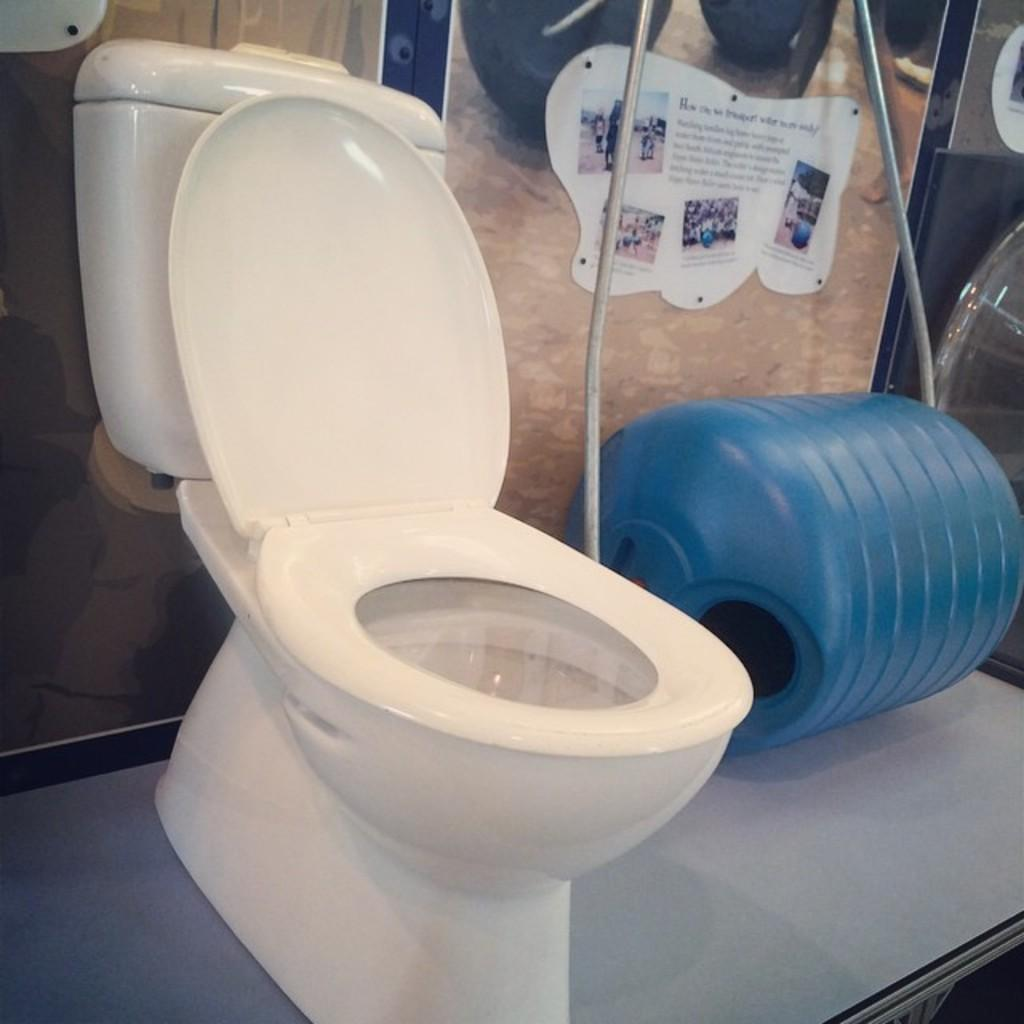Where was the image taken? The image was taken in a washroom. What is the main object in the middle of the image? There is a toilet in the middle of the image. What is the blue-colored object in the middle of the image? There is a blue-colored drum in the middle of the image. What can be seen at the top of the image? There is something pasted at the top of the image. What direction is the washroom facing in the image? The direction the washroom is facing cannot be determined from the image. How long does it take for the toilet to flush in the image? The image does not show the toilet flushing, so it is not possible to determine how long it takes. 